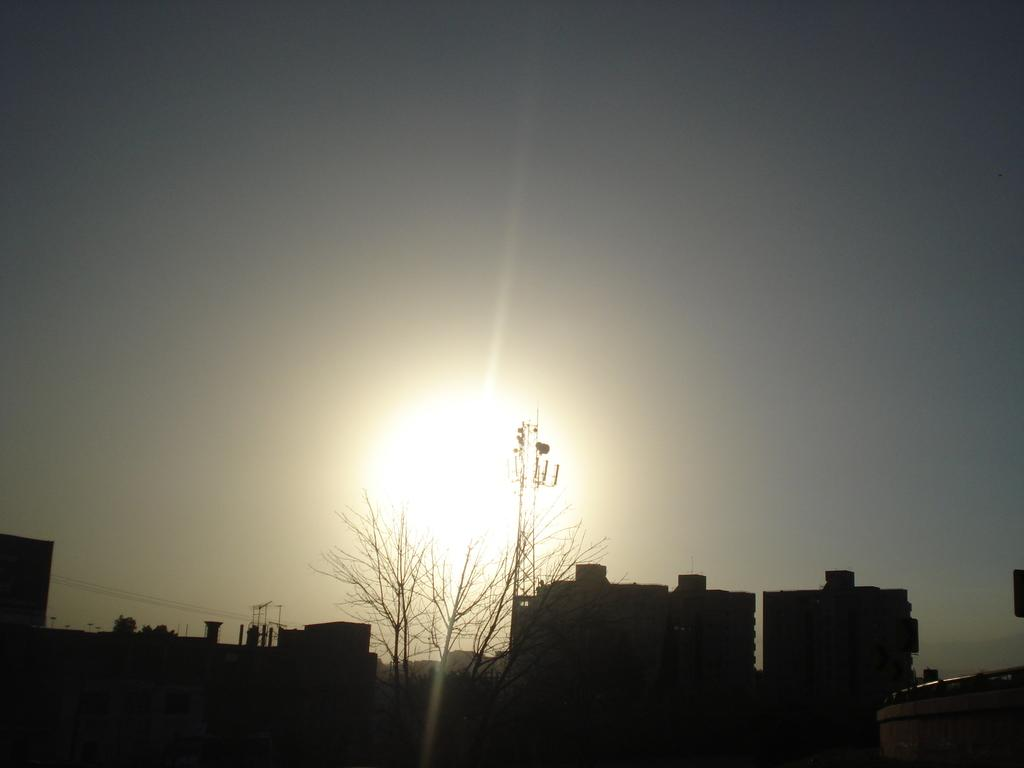What time of day is depicted in the image? The image is taken at the time of sunrise. What can be seen on the right side of the image? There are buildings on the right side of the image. What type of vegetation is visible in the background of the image? There is a plant in the background of the image. What is visible in the sky in the image? The sky is visible in the image. What type of thunder can be heard in the image? There is no sound present in the image, so it is not possible to determine if any thunder can be heard. 